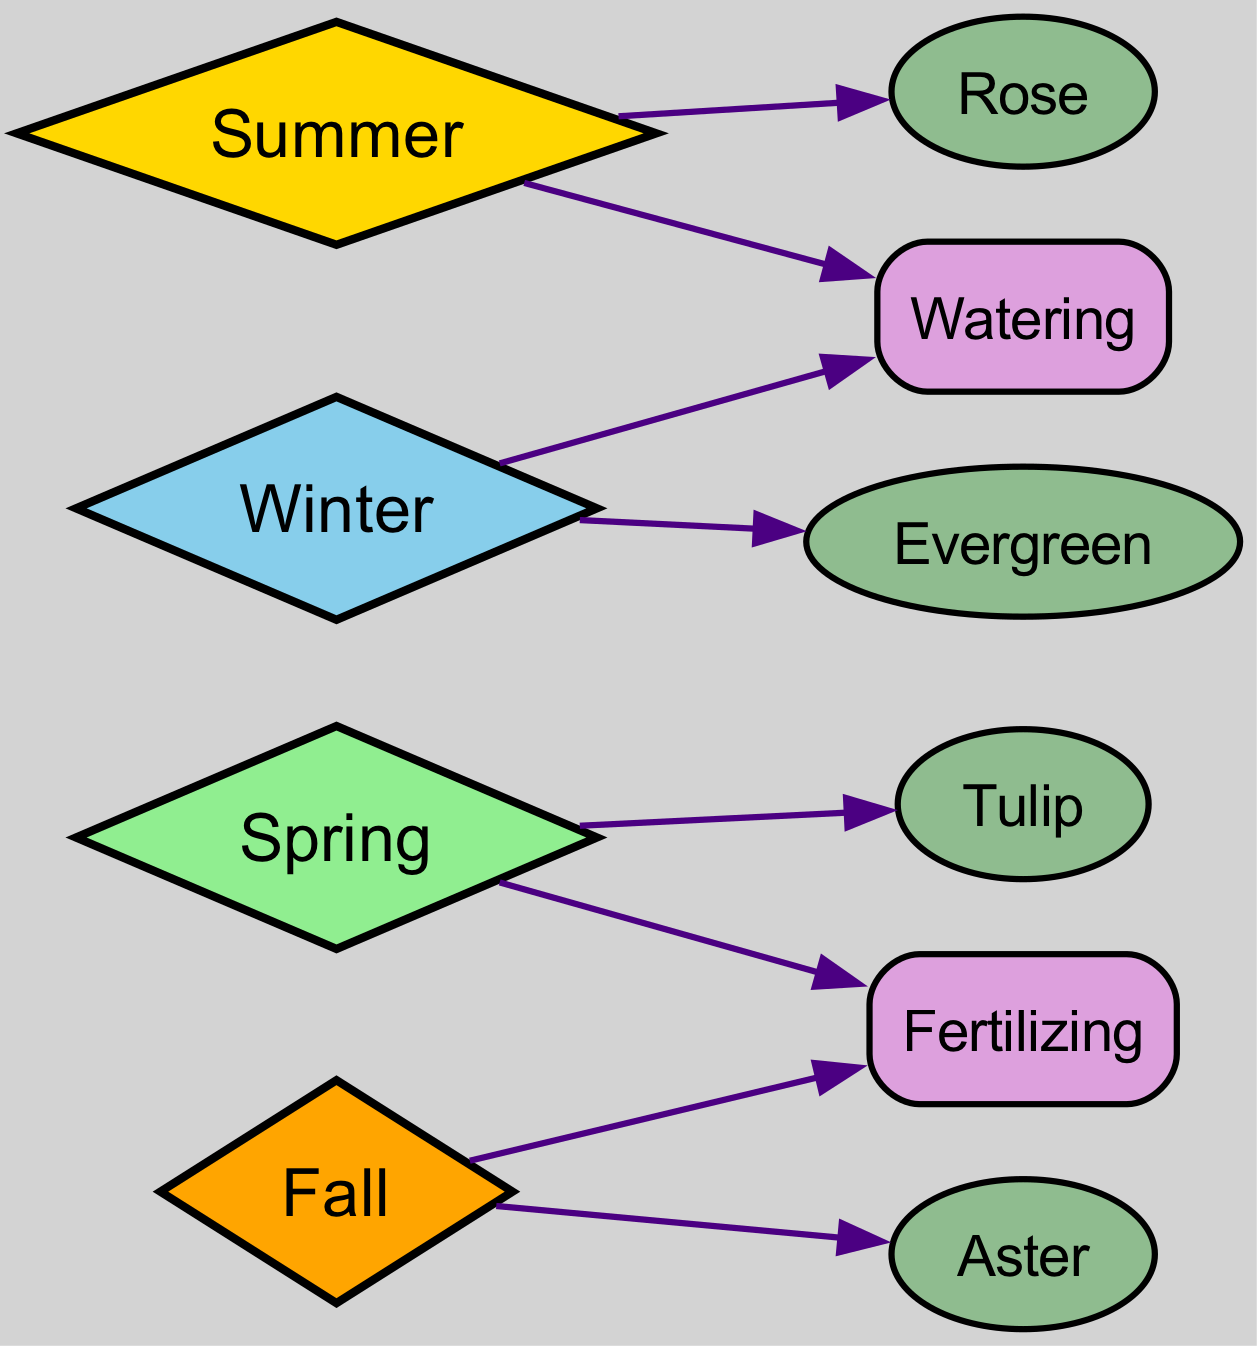What plants are associated with Spring? According to the diagram, Spring is linked to Tulip. Thus, Tulip is the only plant associated with the Spring season in this directed graph.
Answer: Tulip How many care requirements are linked to Summer? The directed graph shows that Summer is connected to Watering, which is one care requirement. Therefore, there is only one care requirement linked to Summer.
Answer: 1 What is the color associated with Fall? The diagram visually represents Fall (a diamond node) with a color that matches the designated color scheme in the code, which specifies Fall's color as orange.
Answer: orange Which two care requirements are mentioned in the diagram? The graph indicates two care requirements: Watering and Fertilizing, both of which stem from the nodes linked to various seasons. Therefore, these are the two care requirements present.
Answer: Watering, Fertilizing How many edges link to the Winter node? The diagram indicates that there are two edges linking to the Winter node, specifically to Evergreen and Watering. Thus, the number of edges connected to Winter is two.
Answer: 2 Which season is linked to Aster? According to the diagram, Fall is the season that connects to Aster. Following the arrows, Aster is derived from the Fall node.
Answer: Fall Are there any plants associated with Winter? The diagram specifies that Winter is linked to Evergreen, indicating there is indeed a plant associated with Winter. Therefore, a plant does exist for this season.
Answer: Evergreen What season requires fertilizing twice? The graph shows that Fertilizing is linked to both Spring and Fall. Therefore, both seasons require fertilizing, leading to the conclusion that Fertilizing is associated with two seasons.
Answer: Spring, Fall Which season connects with both plant types and care requirements? The Summer season connects with both a plant (Rose) and a care requirement (Watering), showing a direct connection to both types in the diagram.
Answer: Summer 